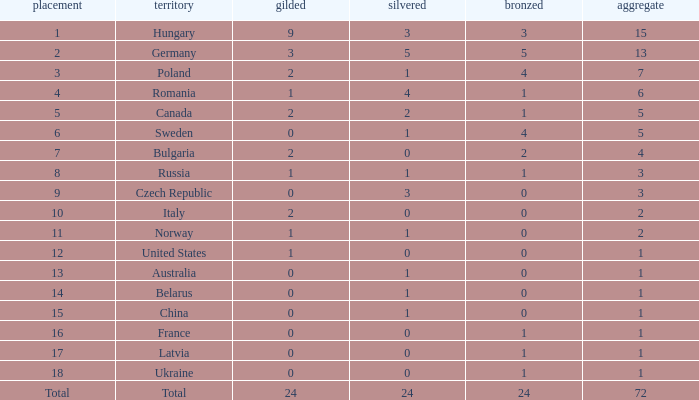What average total has 0 as the gold, with 6 as the rank? 5.0. 